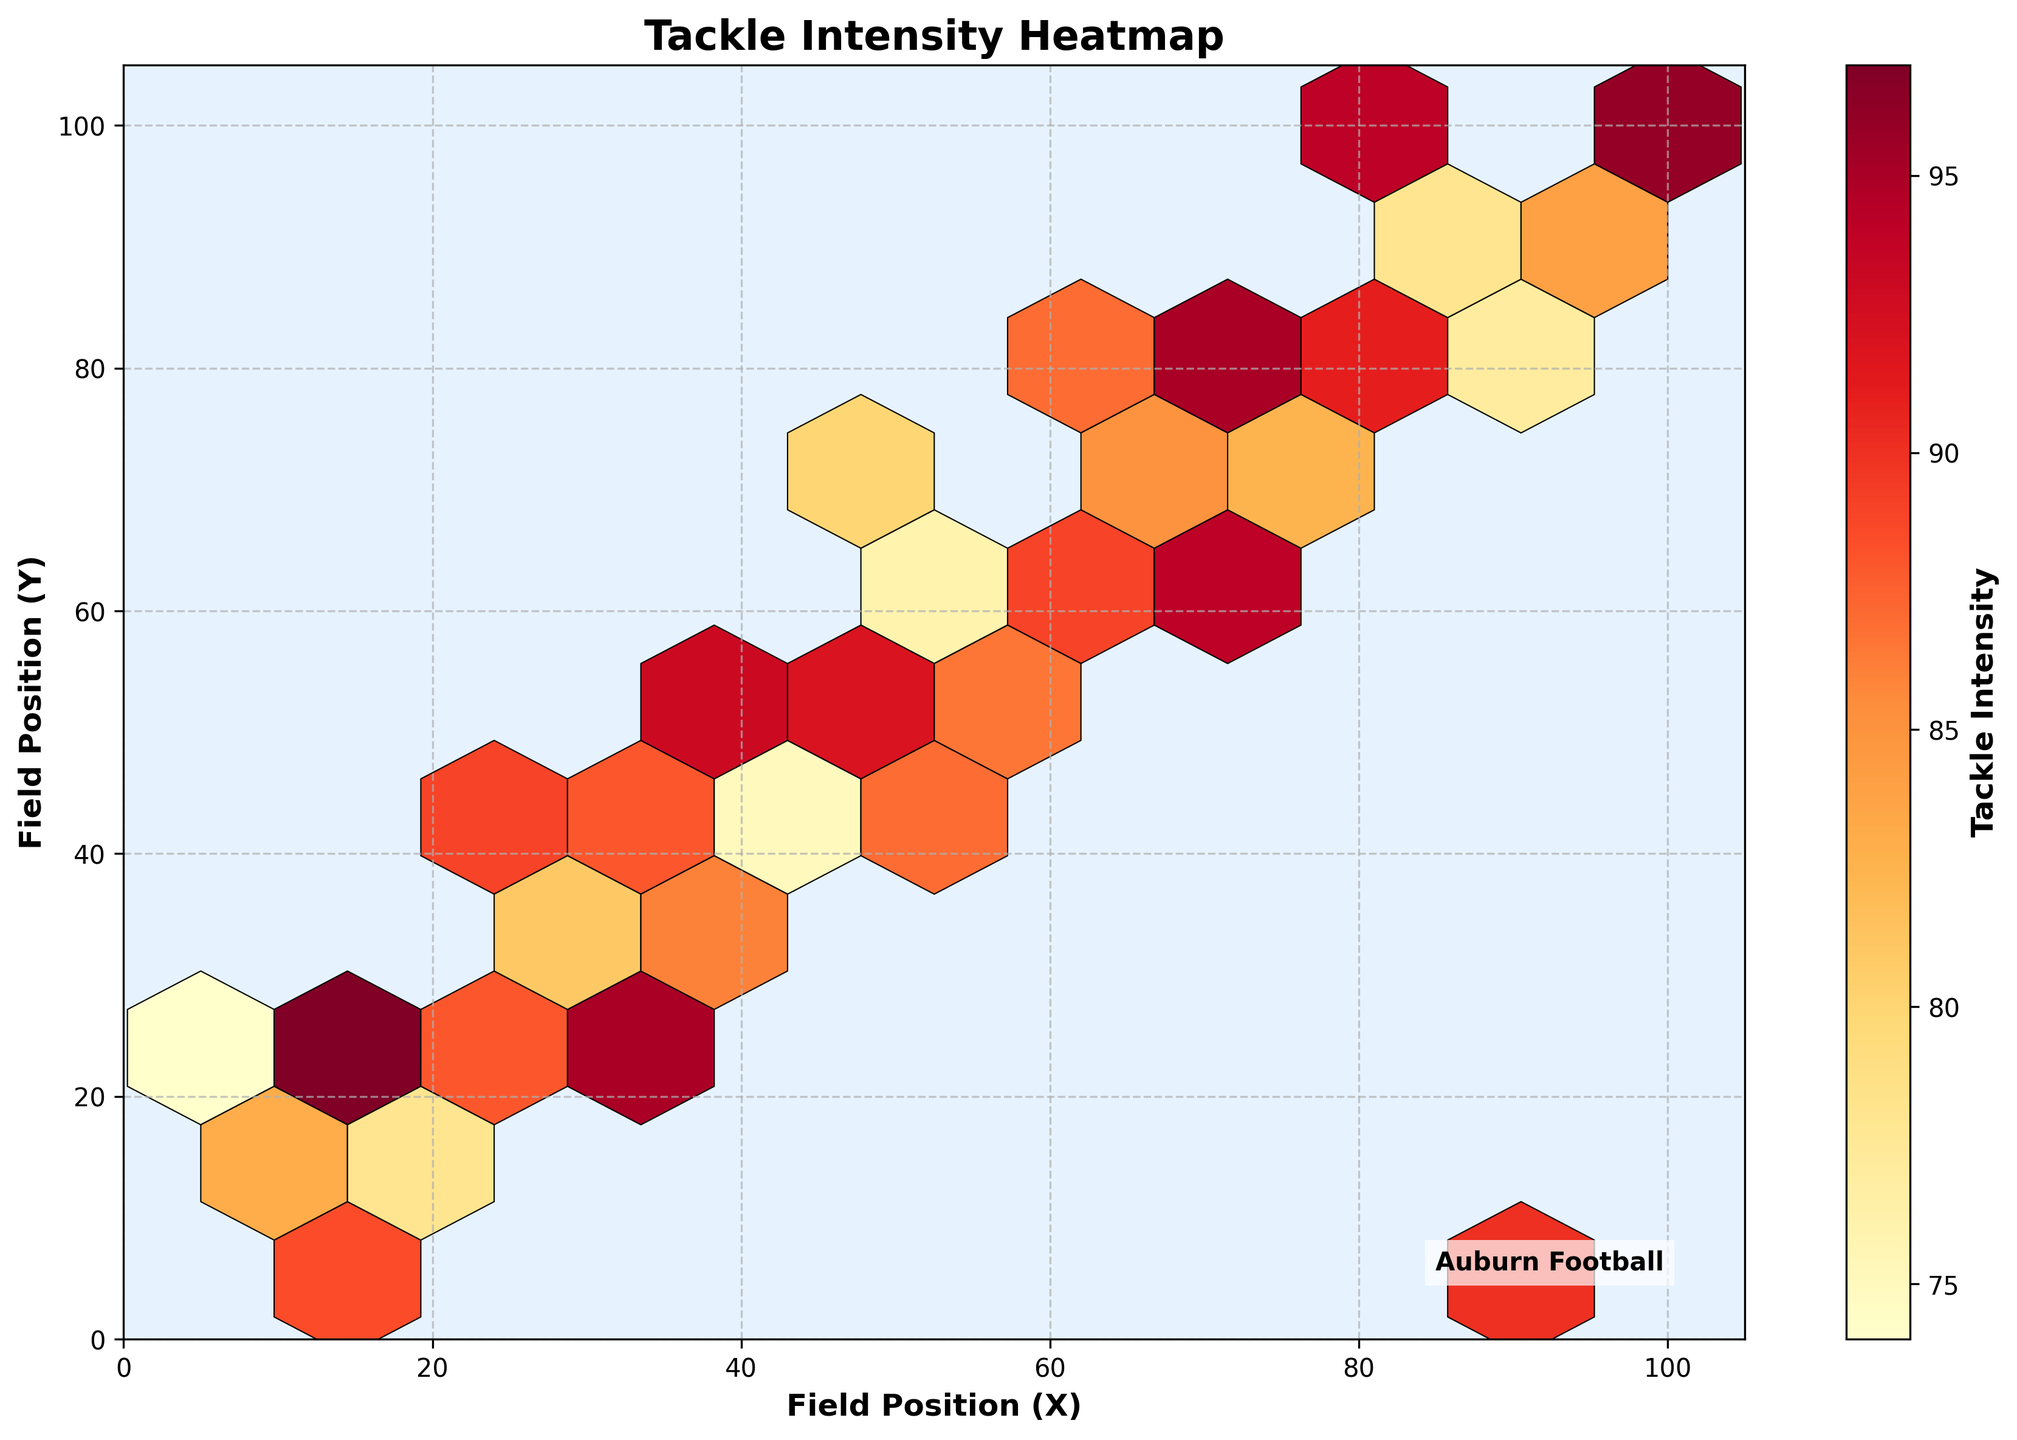what is the title of the figure? The title of the figure is found at the top of the plot and it's often written in larger and bold text.
Answer: Tackle Intensity Heatmap What colors are used to represent different tackle intensities in the plot? Various shades of yellow, orange, and red are used in the plot to represent different tackle intensities. The color transitions from light yellow to dark red as the tackle intensity increases.
Answer: Yellow, orange, red What do the axes represent in the figure? The x-axis represents the field position (X) and the y-axis represents the field position (Y). These are shown on the respective axes in the plot.
Answer: Field positions (X and Y) Where is the field position located with the highest tackle intensity according to the plot? The highest tackle intensity is represented by the darkest red color in the plot. Identifying the hexbin with the darkest red will show the corresponding field position.
Answer: Around (100, 95) How does the tackle intensity vary as the field positions change from lower left to upper right? By observing the gradient and color transition in the hexbin plot from the lower left to the upper right, we can infer whether the tackle intensity increases or decreases. The color appears to transition from lighter colors to darker colors, suggesting there is an increase.
Answer: Increases Which field position range has the least frequency of tackles based on the plot's hexbin color density? The field position range with light yellow or sparsely colored hexagonal bins signifies the area with the least frequency of tackles.
Answer: Around (5, 25) What is the average tackle intensity for field positions (35, 55) and (95, 5)? Identify the specific hex positions mentioned and note their color intensity. Using the color bar as reference, estimate the intensity values and then compute the average of these two values. Estimating from color legend suggests around 88 and 90, respectively.
Answer: (88+90)/2 = 89 Which part of the field shows a higher variance in tackle intensity, the center or the edges? Higher variance is indicated by a more varied range of colors within an area. Look at color consistency in the central region versus the intersecting edges.
Answer: Edges show higher variance Is there a noticeable pattern of tackle intensity closer to either the X-axis or Y-axis? Evaluate the concentration and distribution of colors along the axes and compare if tackle intensities tend to align more closely to one axis.
Answer: Yes, closer to Y-axis What type of color map is used to represent the tackle intensities in the figure? The color map or colormap often refers to a specific palette used to represent quantitative data differences. As inferred from shading in the plot, it appears to be graded from yellow to red.
Answer: YlOrRd 